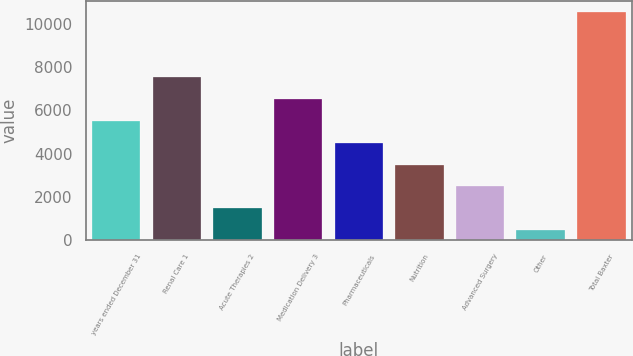Convert chart to OTSL. <chart><loc_0><loc_0><loc_500><loc_500><bar_chart><fcel>years ended December 31<fcel>Renal Care 1<fcel>Acute Therapies 2<fcel>Medication Delivery 3<fcel>Pharmaceuticals<fcel>Nutrition<fcel>Advanced Surgery<fcel>Other<fcel>Total Baxter<nl><fcel>5508<fcel>7529.2<fcel>1465.6<fcel>6518.6<fcel>4497.4<fcel>3486.8<fcel>2476.2<fcel>455<fcel>10561<nl></chart> 